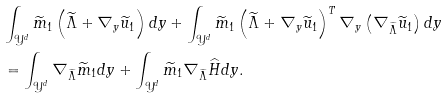Convert formula to latex. <formula><loc_0><loc_0><loc_500><loc_500>& \int _ { \mathcal { Y } ^ { d } } \widetilde { m } _ { 1 } \left ( \widetilde { \Lambda } + \nabla _ { y } \widetilde { u } _ { 1 } \right ) d y + \int _ { \mathcal { Y } ^ { d } } \widetilde { m } _ { 1 } \left ( \widetilde { \Lambda } + \nabla _ { y } \widetilde { u } _ { 1 } \right ) ^ { T } \nabla _ { y } \left ( \nabla _ { \widetilde { \Lambda } } \widetilde { u } _ { 1 } \right ) d y \\ & = \int _ { \mathcal { Y } ^ { d } } \nabla _ { \widetilde { \Lambda } } \widetilde { m } _ { 1 } d y + \int _ { \mathcal { Y } ^ { d } } \widetilde { m } _ { 1 } \nabla _ { \widetilde { \Lambda } } \widehat { H } d y .</formula> 